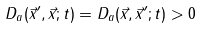Convert formula to latex. <formula><loc_0><loc_0><loc_500><loc_500>D _ { a } ( \vec { x } ^ { \prime } , \vec { x } ; t ) = D _ { a } ( \vec { x } , \vec { x } ^ { \prime } ; t ) > 0</formula> 